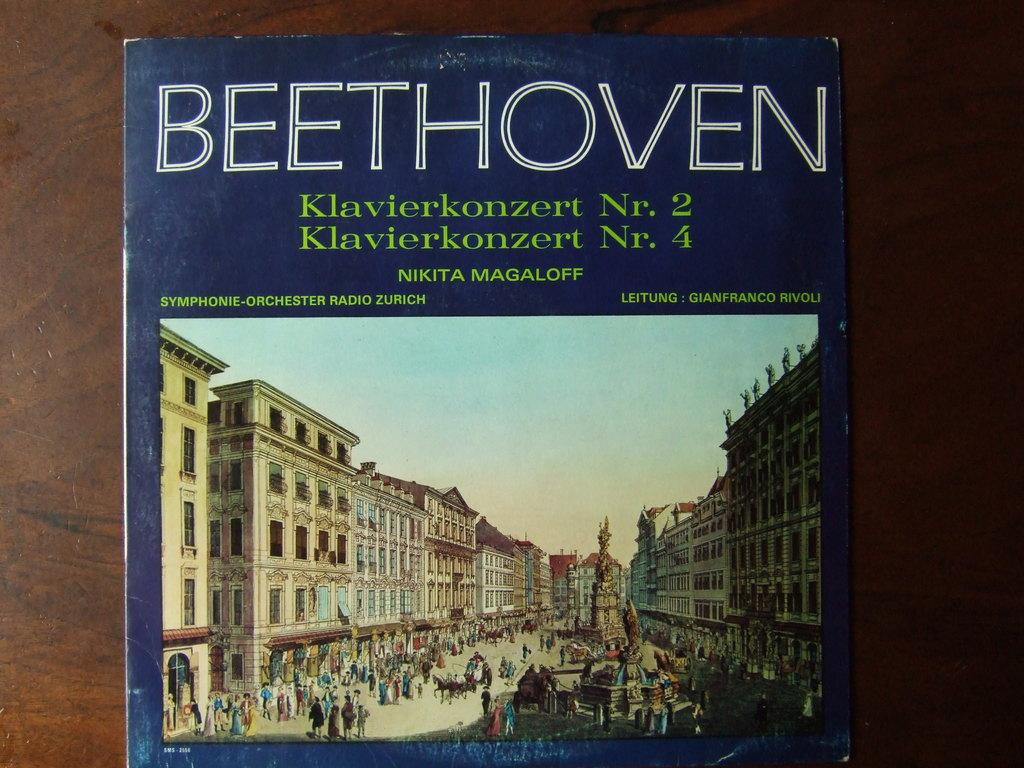<image>
Share a concise interpretation of the image provided. A blue book has the BEETHOVEN on the top and buildings on the photo. 